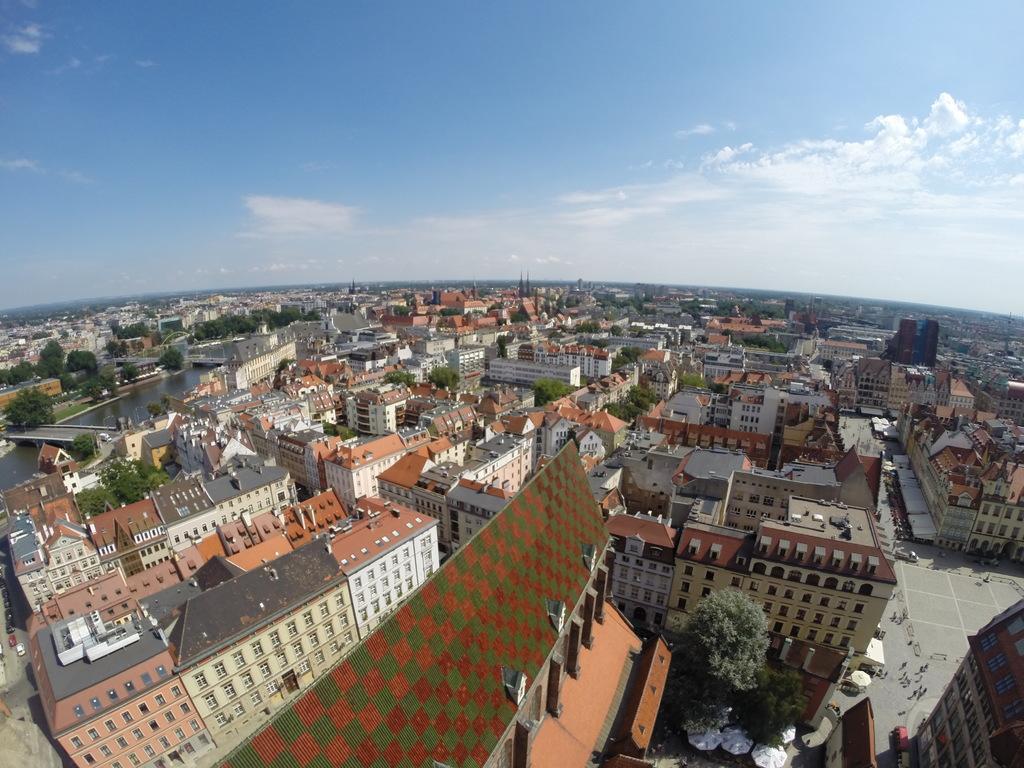Please provide a concise description of this image. In the image there are many buildings with roofs, walls and windows. And also there are trees and roads with few people. On the left side of the image there is water with bridge on it. At the top of the image there is sky with clouds. 